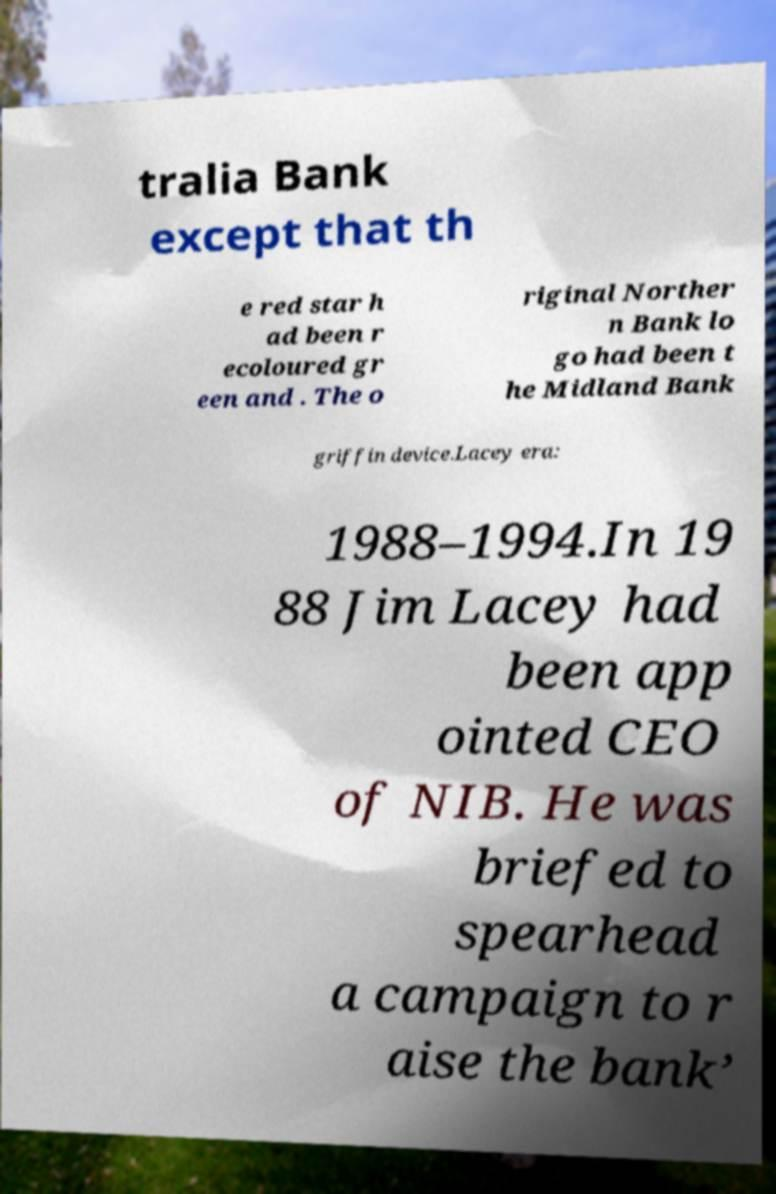Could you assist in decoding the text presented in this image and type it out clearly? tralia Bank except that th e red star h ad been r ecoloured gr een and . The o riginal Norther n Bank lo go had been t he Midland Bank griffin device.Lacey era: 1988–1994.In 19 88 Jim Lacey had been app ointed CEO of NIB. He was briefed to spearhead a campaign to r aise the bank’ 